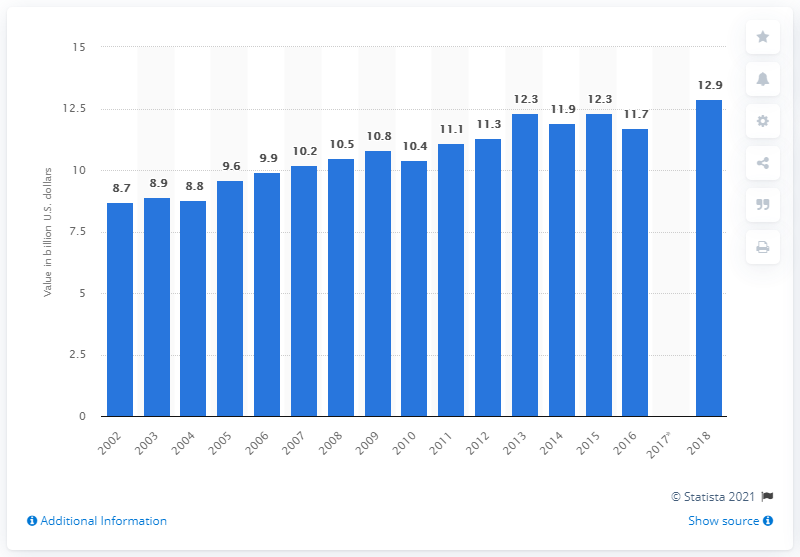Mention a couple of crucial points in this snapshot. In 2018, the value of U.S. product shipments of frozen fruits and vegetables was $12.9 billion. 